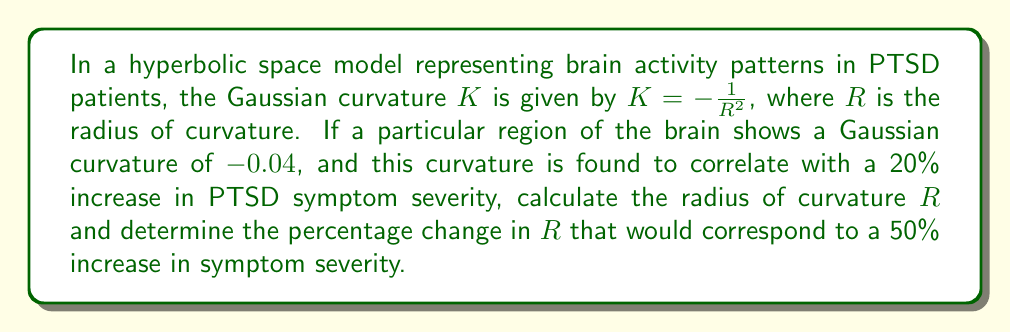Help me with this question. 1) First, let's calculate the radius of curvature $R$ for the given Gaussian curvature:

   $K = -\frac{1}{R^2}$
   $-0.04 = -\frac{1}{R^2}$
   $R^2 = \frac{1}{0.04} = 25$
   $R = 5$ units

2) Now, we know that this curvature (K = -0.04) corresponds to a 20% increase in symptom severity. Let's call the new curvature for a 50% increase in severity $K_{new}$.

3) We can set up a proportion:
   $\frac{20\%}{-0.04} = \frac{50\%}{K_{new}}$

4) Solving for $K_{new}$:
   $K_{new} = \frac{-0.04 \cdot 50\%}{20\%} = -0.1$

5) Now, let's calculate the new radius of curvature $R_{new}$:
   $-0.1 = -\frac{1}{R_{new}^2}$
   $R_{new}^2 = \frac{1}{0.1} = 10$
   $R_{new} = \sqrt{10} \approx 3.16$ units

6) To find the percentage change in $R$:
   Percentage change = $\frac{R_{new} - R}{R} \cdot 100\%$
                     = $\frac{3.16 - 5}{5} \cdot 100\%$
                     = $-36.8\%$

Therefore, a decrease of approximately 36.8% in the radius of curvature corresponds to a 50% increase in symptom severity.
Answer: $R = 5$ units; $-36.8\%$ change in $R$ 